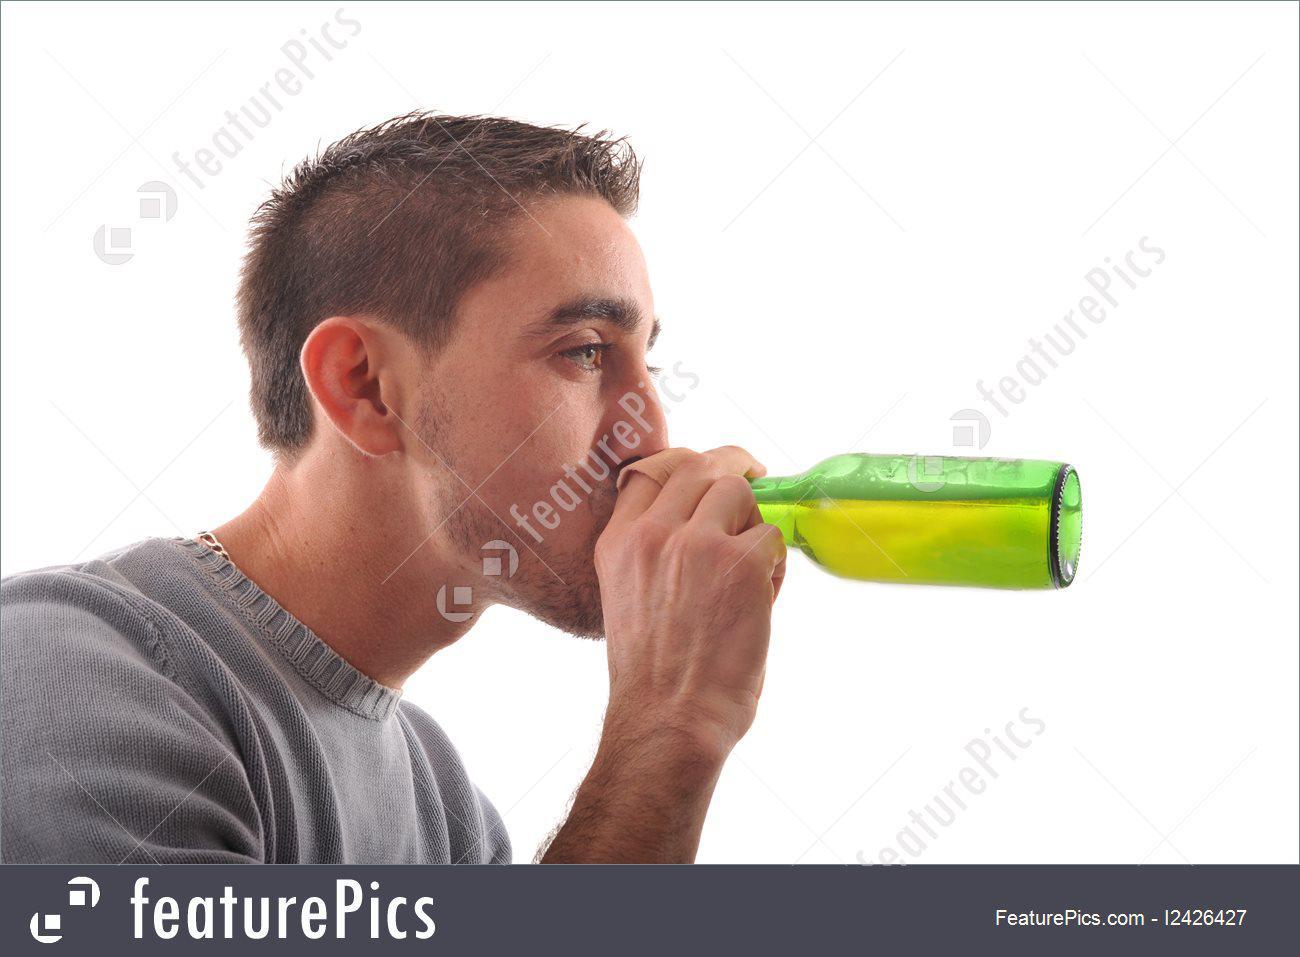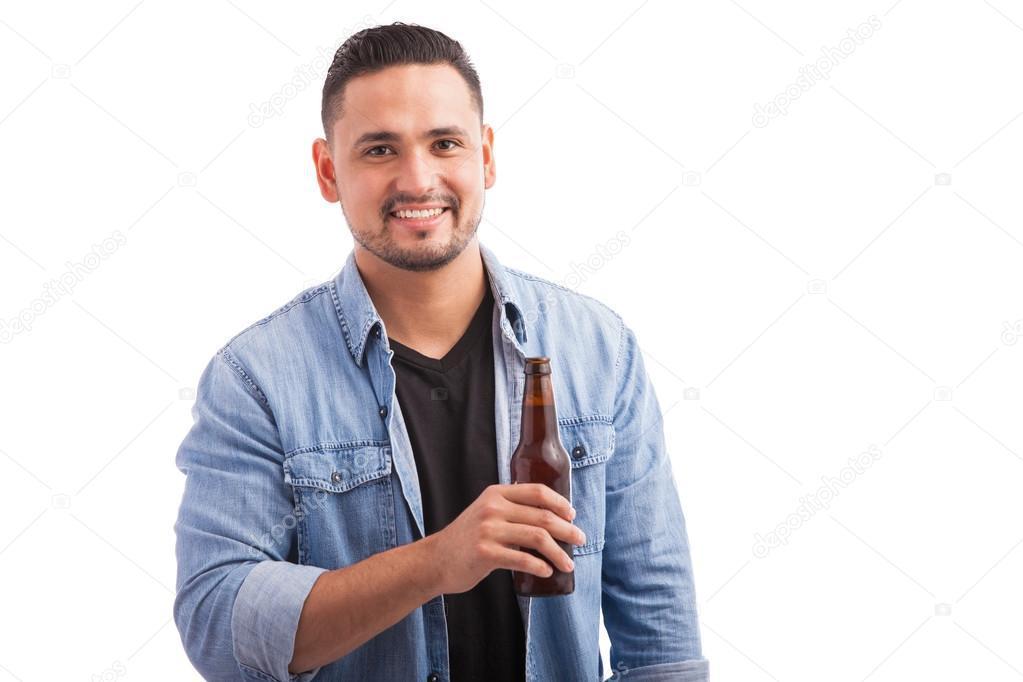The first image is the image on the left, the second image is the image on the right. Given the left and right images, does the statement "There is a total of three bottles or cans of beer." hold true? Answer yes or no. No. The first image is the image on the left, the second image is the image on the right. For the images displayed, is the sentence "The man in the image on the left is holding a green bottle." factually correct? Answer yes or no. Yes. 